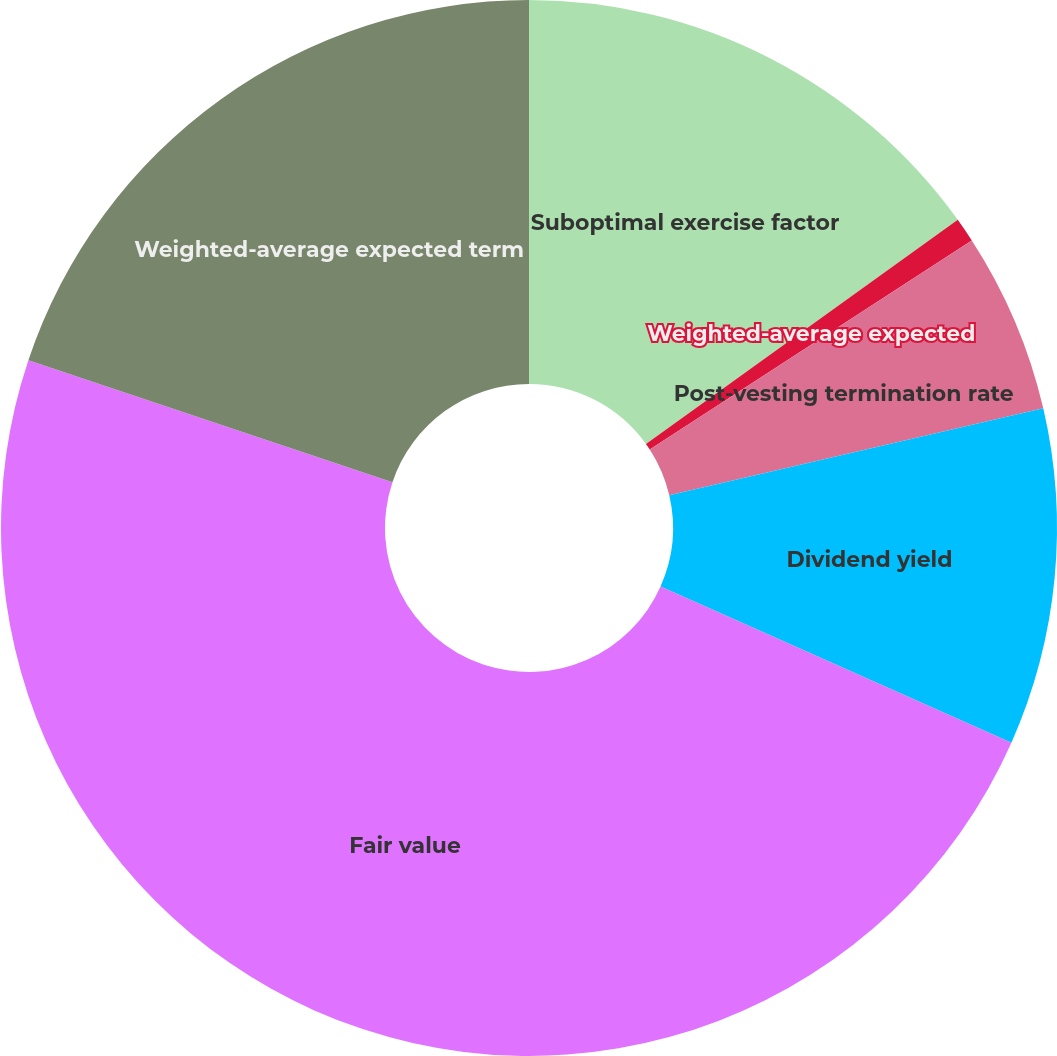<chart> <loc_0><loc_0><loc_500><loc_500><pie_chart><fcel>Suboptimal exercise factor<fcel>Weighted-average expected<fcel>Post-vesting termination rate<fcel>Dividend yield<fcel>Fair value<fcel>Weighted-average expected term<nl><fcel>15.08%<fcel>0.75%<fcel>5.53%<fcel>10.3%<fcel>48.48%<fcel>19.85%<nl></chart> 